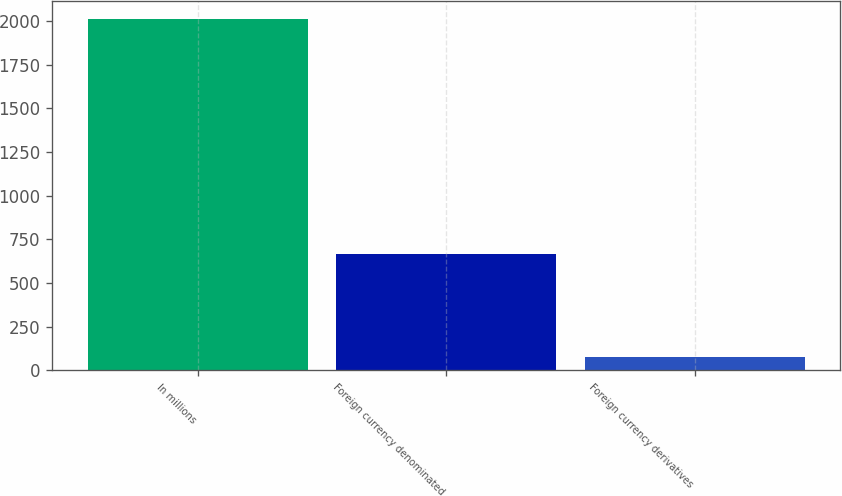Convert chart. <chart><loc_0><loc_0><loc_500><loc_500><bar_chart><fcel>In millions<fcel>Foreign currency denominated<fcel>Foreign currency derivatives<nl><fcel>2015<fcel>668.1<fcel>79.1<nl></chart> 